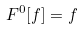<formula> <loc_0><loc_0><loc_500><loc_500>F ^ { 0 } [ f ] = f</formula> 